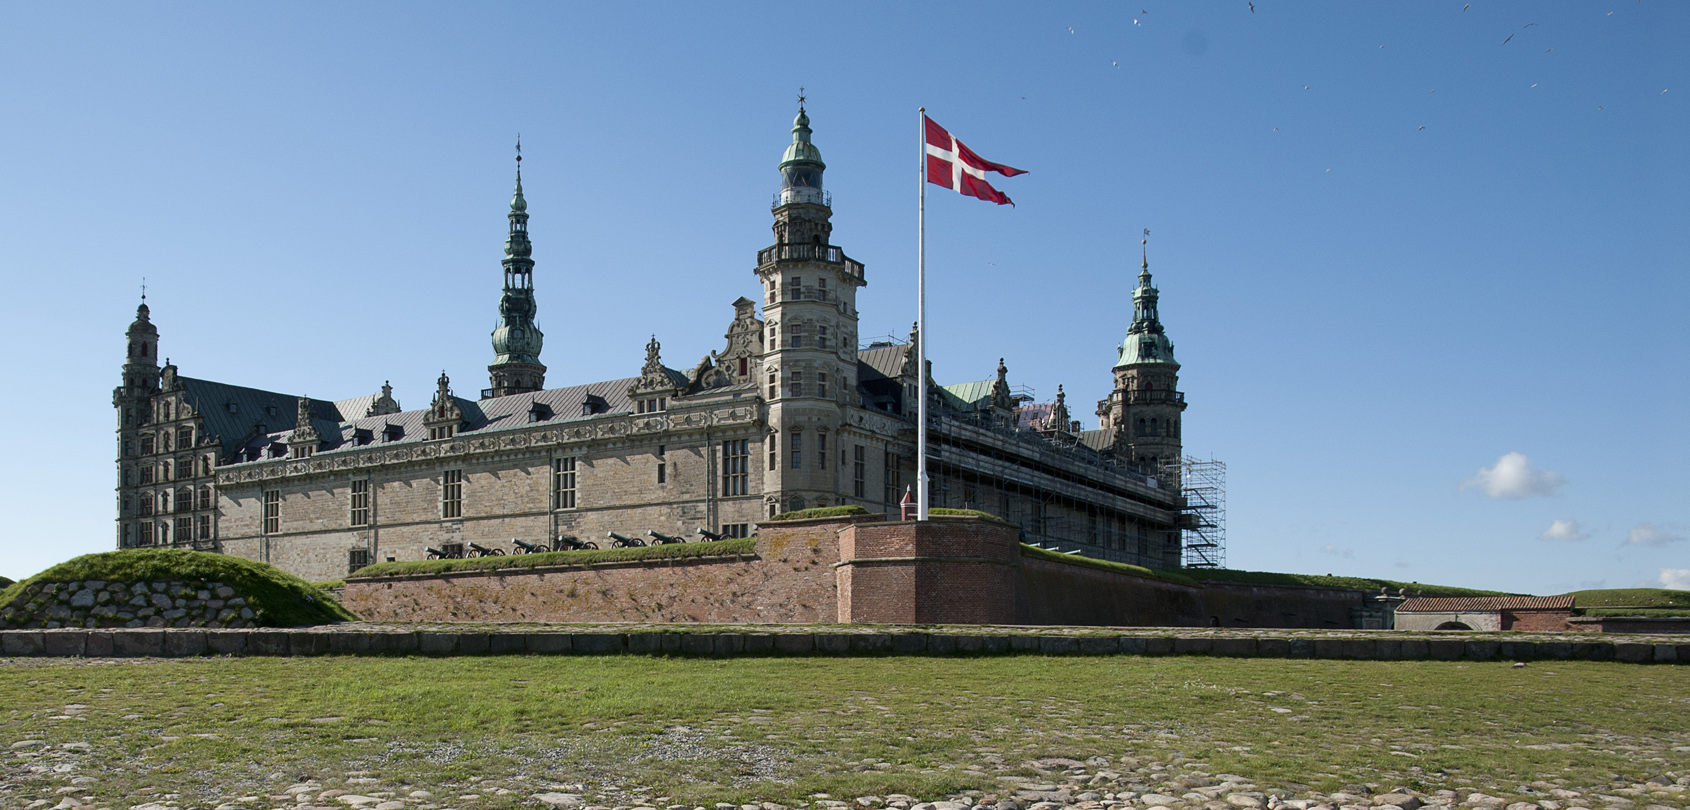Describe a realistic day in the life of someone who might have lived in this castle during the Renaissance. A typical day for a noble residing in Kronborg Castle during the Renaissance would start with the gentle light of dawn streaming through their chamber windows. After waking, they would be attended by servants who assisted with dressing in elaborate, elegant attire befitting their status. Breakfast would be taken in the grand dining hall, consisting of fresh bread, fruits, and meats prepared by the castle cooks. The mornings were often spent attending to courtly duties, such as overseeing the household, receiving guests, or engaging in strategic discussions with fellow nobles and military advisors. Midday would bring a hearty lunch, followed by leisurely activities like walking through the castle gardens, hunting in the surrounding woodlands, or enjoying music and poetry recitals. Afternoons might include attending or hosting a small court gathering or even a grand ball, where dance and entertainment were central. As evening fell, a sumptuous dinner would be served, and the noble might retire to their chambers for private reflection, reading, or intimate conversations with close companions. The castle buzzed with a mix of responsibility, luxury, and cultural enrichment, embodying the splendor of Renaissance life. 